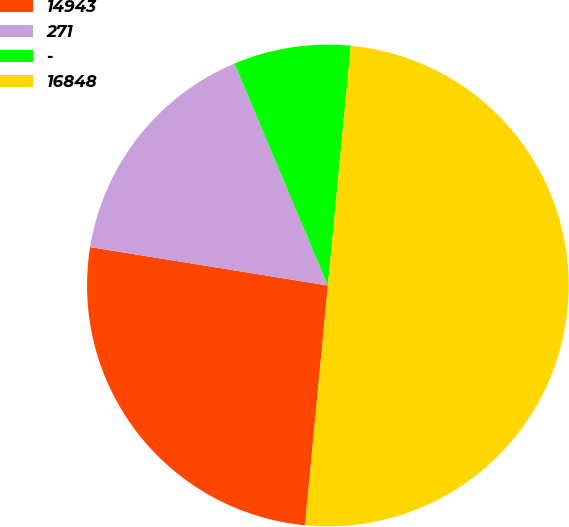Convert chart. <chart><loc_0><loc_0><loc_500><loc_500><pie_chart><fcel>14943<fcel>271<fcel>-<fcel>16848<nl><fcel>26.04%<fcel>16.11%<fcel>7.86%<fcel>50.0%<nl></chart> 